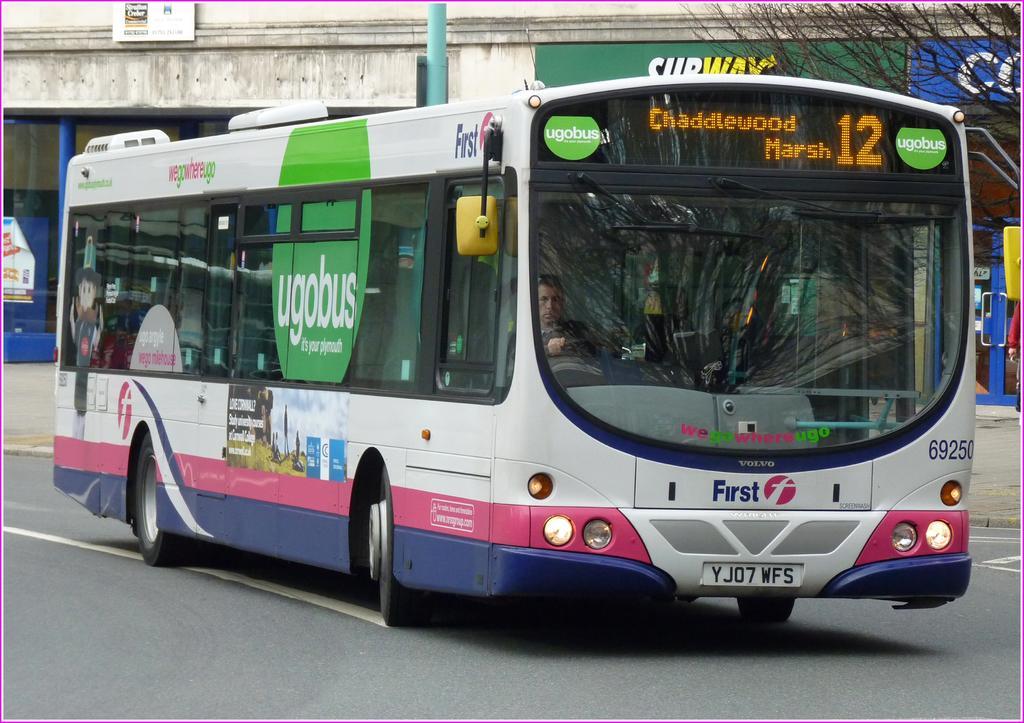Could you give a brief overview of what you see in this image? In this image we can see a bus on the road, there is a driver in the driver seat inside the bus. 